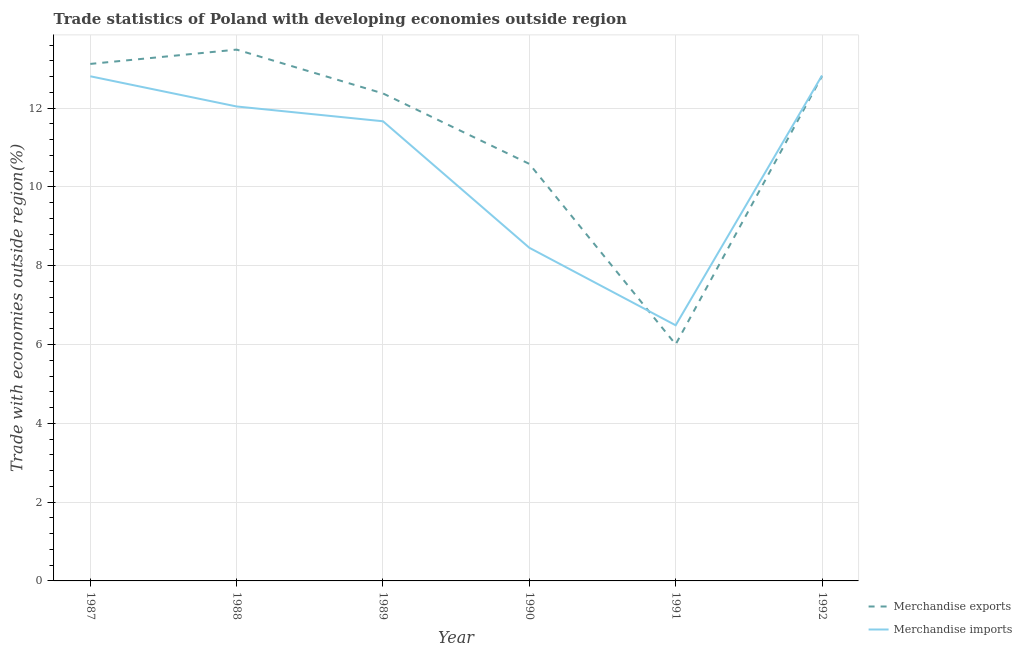How many different coloured lines are there?
Make the answer very short. 2. Is the number of lines equal to the number of legend labels?
Offer a very short reply. Yes. What is the merchandise imports in 1989?
Your answer should be very brief. 11.67. Across all years, what is the maximum merchandise imports?
Provide a short and direct response. 12.83. Across all years, what is the minimum merchandise imports?
Offer a very short reply. 6.49. In which year was the merchandise exports maximum?
Ensure brevity in your answer.  1988. What is the total merchandise imports in the graph?
Provide a succinct answer. 64.28. What is the difference between the merchandise imports in 1989 and that in 1990?
Your response must be concise. 3.21. What is the difference between the merchandise imports in 1989 and the merchandise exports in 1992?
Ensure brevity in your answer.  -1.14. What is the average merchandise imports per year?
Make the answer very short. 10.71. In the year 1990, what is the difference between the merchandise imports and merchandise exports?
Offer a very short reply. -2.13. What is the ratio of the merchandise exports in 1990 to that in 1992?
Give a very brief answer. 0.83. Is the merchandise imports in 1989 less than that in 1991?
Your answer should be compact. No. Is the difference between the merchandise exports in 1991 and 1992 greater than the difference between the merchandise imports in 1991 and 1992?
Offer a terse response. No. What is the difference between the highest and the second highest merchandise imports?
Ensure brevity in your answer.  0.02. What is the difference between the highest and the lowest merchandise exports?
Provide a short and direct response. 7.48. In how many years, is the merchandise imports greater than the average merchandise imports taken over all years?
Your answer should be compact. 4. How many years are there in the graph?
Make the answer very short. 6. What is the difference between two consecutive major ticks on the Y-axis?
Ensure brevity in your answer.  2. Are the values on the major ticks of Y-axis written in scientific E-notation?
Keep it short and to the point. No. Does the graph contain any zero values?
Ensure brevity in your answer.  No. Does the graph contain grids?
Offer a terse response. Yes. Where does the legend appear in the graph?
Your answer should be very brief. Bottom right. How many legend labels are there?
Keep it short and to the point. 2. What is the title of the graph?
Make the answer very short. Trade statistics of Poland with developing economies outside region. Does "Tetanus" appear as one of the legend labels in the graph?
Provide a succinct answer. No. What is the label or title of the X-axis?
Your response must be concise. Year. What is the label or title of the Y-axis?
Offer a very short reply. Trade with economies outside region(%). What is the Trade with economies outside region(%) of Merchandise exports in 1987?
Your answer should be compact. 13.12. What is the Trade with economies outside region(%) in Merchandise imports in 1987?
Your response must be concise. 12.81. What is the Trade with economies outside region(%) of Merchandise exports in 1988?
Give a very brief answer. 13.48. What is the Trade with economies outside region(%) of Merchandise imports in 1988?
Give a very brief answer. 12.04. What is the Trade with economies outside region(%) in Merchandise exports in 1989?
Your response must be concise. 12.37. What is the Trade with economies outside region(%) in Merchandise imports in 1989?
Make the answer very short. 11.67. What is the Trade with economies outside region(%) in Merchandise exports in 1990?
Offer a very short reply. 10.58. What is the Trade with economies outside region(%) in Merchandise imports in 1990?
Provide a succinct answer. 8.45. What is the Trade with economies outside region(%) in Merchandise exports in 1991?
Provide a succinct answer. 6. What is the Trade with economies outside region(%) of Merchandise imports in 1991?
Your answer should be very brief. 6.49. What is the Trade with economies outside region(%) in Merchandise exports in 1992?
Your response must be concise. 12.81. What is the Trade with economies outside region(%) of Merchandise imports in 1992?
Offer a very short reply. 12.83. Across all years, what is the maximum Trade with economies outside region(%) of Merchandise exports?
Provide a succinct answer. 13.48. Across all years, what is the maximum Trade with economies outside region(%) in Merchandise imports?
Make the answer very short. 12.83. Across all years, what is the minimum Trade with economies outside region(%) of Merchandise exports?
Your response must be concise. 6. Across all years, what is the minimum Trade with economies outside region(%) of Merchandise imports?
Your response must be concise. 6.49. What is the total Trade with economies outside region(%) in Merchandise exports in the graph?
Offer a terse response. 68.38. What is the total Trade with economies outside region(%) of Merchandise imports in the graph?
Your answer should be compact. 64.28. What is the difference between the Trade with economies outside region(%) in Merchandise exports in 1987 and that in 1988?
Ensure brevity in your answer.  -0.36. What is the difference between the Trade with economies outside region(%) of Merchandise imports in 1987 and that in 1988?
Offer a very short reply. 0.77. What is the difference between the Trade with economies outside region(%) in Merchandise exports in 1987 and that in 1989?
Your answer should be very brief. 0.75. What is the difference between the Trade with economies outside region(%) in Merchandise imports in 1987 and that in 1989?
Make the answer very short. 1.14. What is the difference between the Trade with economies outside region(%) of Merchandise exports in 1987 and that in 1990?
Provide a succinct answer. 2.54. What is the difference between the Trade with economies outside region(%) in Merchandise imports in 1987 and that in 1990?
Offer a very short reply. 4.35. What is the difference between the Trade with economies outside region(%) of Merchandise exports in 1987 and that in 1991?
Offer a very short reply. 7.12. What is the difference between the Trade with economies outside region(%) of Merchandise imports in 1987 and that in 1991?
Provide a succinct answer. 6.32. What is the difference between the Trade with economies outside region(%) in Merchandise exports in 1987 and that in 1992?
Offer a terse response. 0.31. What is the difference between the Trade with economies outside region(%) of Merchandise imports in 1987 and that in 1992?
Keep it short and to the point. -0.02. What is the difference between the Trade with economies outside region(%) of Merchandise exports in 1988 and that in 1989?
Your response must be concise. 1.11. What is the difference between the Trade with economies outside region(%) of Merchandise imports in 1988 and that in 1989?
Keep it short and to the point. 0.38. What is the difference between the Trade with economies outside region(%) of Merchandise exports in 1988 and that in 1990?
Offer a very short reply. 2.9. What is the difference between the Trade with economies outside region(%) in Merchandise imports in 1988 and that in 1990?
Offer a terse response. 3.59. What is the difference between the Trade with economies outside region(%) of Merchandise exports in 1988 and that in 1991?
Offer a very short reply. 7.48. What is the difference between the Trade with economies outside region(%) of Merchandise imports in 1988 and that in 1991?
Keep it short and to the point. 5.55. What is the difference between the Trade with economies outside region(%) of Merchandise exports in 1988 and that in 1992?
Provide a short and direct response. 0.67. What is the difference between the Trade with economies outside region(%) of Merchandise imports in 1988 and that in 1992?
Your response must be concise. -0.79. What is the difference between the Trade with economies outside region(%) in Merchandise exports in 1989 and that in 1990?
Your response must be concise. 1.79. What is the difference between the Trade with economies outside region(%) of Merchandise imports in 1989 and that in 1990?
Offer a terse response. 3.21. What is the difference between the Trade with economies outside region(%) of Merchandise exports in 1989 and that in 1991?
Ensure brevity in your answer.  6.37. What is the difference between the Trade with economies outside region(%) in Merchandise imports in 1989 and that in 1991?
Your response must be concise. 5.18. What is the difference between the Trade with economies outside region(%) of Merchandise exports in 1989 and that in 1992?
Your response must be concise. -0.44. What is the difference between the Trade with economies outside region(%) in Merchandise imports in 1989 and that in 1992?
Keep it short and to the point. -1.16. What is the difference between the Trade with economies outside region(%) of Merchandise exports in 1990 and that in 1991?
Provide a succinct answer. 4.58. What is the difference between the Trade with economies outside region(%) in Merchandise imports in 1990 and that in 1991?
Offer a terse response. 1.97. What is the difference between the Trade with economies outside region(%) in Merchandise exports in 1990 and that in 1992?
Keep it short and to the point. -2.23. What is the difference between the Trade with economies outside region(%) in Merchandise imports in 1990 and that in 1992?
Your answer should be compact. -4.37. What is the difference between the Trade with economies outside region(%) in Merchandise exports in 1991 and that in 1992?
Your answer should be very brief. -6.81. What is the difference between the Trade with economies outside region(%) of Merchandise imports in 1991 and that in 1992?
Offer a terse response. -6.34. What is the difference between the Trade with economies outside region(%) of Merchandise exports in 1987 and the Trade with economies outside region(%) of Merchandise imports in 1988?
Ensure brevity in your answer.  1.08. What is the difference between the Trade with economies outside region(%) in Merchandise exports in 1987 and the Trade with economies outside region(%) in Merchandise imports in 1989?
Make the answer very short. 1.46. What is the difference between the Trade with economies outside region(%) in Merchandise exports in 1987 and the Trade with economies outside region(%) in Merchandise imports in 1990?
Give a very brief answer. 4.67. What is the difference between the Trade with economies outside region(%) of Merchandise exports in 1987 and the Trade with economies outside region(%) of Merchandise imports in 1991?
Your answer should be compact. 6.63. What is the difference between the Trade with economies outside region(%) of Merchandise exports in 1987 and the Trade with economies outside region(%) of Merchandise imports in 1992?
Offer a very short reply. 0.29. What is the difference between the Trade with economies outside region(%) in Merchandise exports in 1988 and the Trade with economies outside region(%) in Merchandise imports in 1989?
Offer a terse response. 1.82. What is the difference between the Trade with economies outside region(%) of Merchandise exports in 1988 and the Trade with economies outside region(%) of Merchandise imports in 1990?
Keep it short and to the point. 5.03. What is the difference between the Trade with economies outside region(%) in Merchandise exports in 1988 and the Trade with economies outside region(%) in Merchandise imports in 1991?
Your response must be concise. 7. What is the difference between the Trade with economies outside region(%) of Merchandise exports in 1988 and the Trade with economies outside region(%) of Merchandise imports in 1992?
Give a very brief answer. 0.66. What is the difference between the Trade with economies outside region(%) of Merchandise exports in 1989 and the Trade with economies outside region(%) of Merchandise imports in 1990?
Provide a succinct answer. 3.92. What is the difference between the Trade with economies outside region(%) of Merchandise exports in 1989 and the Trade with economies outside region(%) of Merchandise imports in 1991?
Offer a very short reply. 5.88. What is the difference between the Trade with economies outside region(%) in Merchandise exports in 1989 and the Trade with economies outside region(%) in Merchandise imports in 1992?
Provide a succinct answer. -0.46. What is the difference between the Trade with economies outside region(%) of Merchandise exports in 1990 and the Trade with economies outside region(%) of Merchandise imports in 1991?
Your answer should be compact. 4.1. What is the difference between the Trade with economies outside region(%) in Merchandise exports in 1990 and the Trade with economies outside region(%) in Merchandise imports in 1992?
Offer a terse response. -2.24. What is the difference between the Trade with economies outside region(%) in Merchandise exports in 1991 and the Trade with economies outside region(%) in Merchandise imports in 1992?
Keep it short and to the point. -6.82. What is the average Trade with economies outside region(%) in Merchandise exports per year?
Make the answer very short. 11.4. What is the average Trade with economies outside region(%) in Merchandise imports per year?
Your answer should be very brief. 10.71. In the year 1987, what is the difference between the Trade with economies outside region(%) in Merchandise exports and Trade with economies outside region(%) in Merchandise imports?
Provide a succinct answer. 0.31. In the year 1988, what is the difference between the Trade with economies outside region(%) of Merchandise exports and Trade with economies outside region(%) of Merchandise imports?
Provide a short and direct response. 1.44. In the year 1989, what is the difference between the Trade with economies outside region(%) in Merchandise exports and Trade with economies outside region(%) in Merchandise imports?
Provide a short and direct response. 0.71. In the year 1990, what is the difference between the Trade with economies outside region(%) of Merchandise exports and Trade with economies outside region(%) of Merchandise imports?
Offer a terse response. 2.13. In the year 1991, what is the difference between the Trade with economies outside region(%) of Merchandise exports and Trade with economies outside region(%) of Merchandise imports?
Ensure brevity in your answer.  -0.48. In the year 1992, what is the difference between the Trade with economies outside region(%) of Merchandise exports and Trade with economies outside region(%) of Merchandise imports?
Keep it short and to the point. -0.02. What is the ratio of the Trade with economies outside region(%) in Merchandise exports in 1987 to that in 1988?
Give a very brief answer. 0.97. What is the ratio of the Trade with economies outside region(%) of Merchandise imports in 1987 to that in 1988?
Keep it short and to the point. 1.06. What is the ratio of the Trade with economies outside region(%) of Merchandise exports in 1987 to that in 1989?
Give a very brief answer. 1.06. What is the ratio of the Trade with economies outside region(%) of Merchandise imports in 1987 to that in 1989?
Your answer should be very brief. 1.1. What is the ratio of the Trade with economies outside region(%) in Merchandise exports in 1987 to that in 1990?
Ensure brevity in your answer.  1.24. What is the ratio of the Trade with economies outside region(%) in Merchandise imports in 1987 to that in 1990?
Ensure brevity in your answer.  1.51. What is the ratio of the Trade with economies outside region(%) of Merchandise exports in 1987 to that in 1991?
Your response must be concise. 2.19. What is the ratio of the Trade with economies outside region(%) in Merchandise imports in 1987 to that in 1991?
Give a very brief answer. 1.97. What is the ratio of the Trade with economies outside region(%) of Merchandise exports in 1987 to that in 1992?
Give a very brief answer. 1.02. What is the ratio of the Trade with economies outside region(%) of Merchandise exports in 1988 to that in 1989?
Make the answer very short. 1.09. What is the ratio of the Trade with economies outside region(%) of Merchandise imports in 1988 to that in 1989?
Your response must be concise. 1.03. What is the ratio of the Trade with economies outside region(%) of Merchandise exports in 1988 to that in 1990?
Provide a short and direct response. 1.27. What is the ratio of the Trade with economies outside region(%) in Merchandise imports in 1988 to that in 1990?
Ensure brevity in your answer.  1.42. What is the ratio of the Trade with economies outside region(%) of Merchandise exports in 1988 to that in 1991?
Keep it short and to the point. 2.25. What is the ratio of the Trade with economies outside region(%) of Merchandise imports in 1988 to that in 1991?
Your answer should be compact. 1.86. What is the ratio of the Trade with economies outside region(%) of Merchandise exports in 1988 to that in 1992?
Offer a terse response. 1.05. What is the ratio of the Trade with economies outside region(%) in Merchandise imports in 1988 to that in 1992?
Ensure brevity in your answer.  0.94. What is the ratio of the Trade with economies outside region(%) in Merchandise exports in 1989 to that in 1990?
Provide a succinct answer. 1.17. What is the ratio of the Trade with economies outside region(%) in Merchandise imports in 1989 to that in 1990?
Your answer should be compact. 1.38. What is the ratio of the Trade with economies outside region(%) in Merchandise exports in 1989 to that in 1991?
Offer a terse response. 2.06. What is the ratio of the Trade with economies outside region(%) in Merchandise imports in 1989 to that in 1991?
Provide a succinct answer. 1.8. What is the ratio of the Trade with economies outside region(%) of Merchandise exports in 1989 to that in 1992?
Give a very brief answer. 0.97. What is the ratio of the Trade with economies outside region(%) in Merchandise imports in 1989 to that in 1992?
Keep it short and to the point. 0.91. What is the ratio of the Trade with economies outside region(%) of Merchandise exports in 1990 to that in 1991?
Make the answer very short. 1.76. What is the ratio of the Trade with economies outside region(%) in Merchandise imports in 1990 to that in 1991?
Keep it short and to the point. 1.3. What is the ratio of the Trade with economies outside region(%) in Merchandise exports in 1990 to that in 1992?
Provide a succinct answer. 0.83. What is the ratio of the Trade with economies outside region(%) in Merchandise imports in 1990 to that in 1992?
Offer a very short reply. 0.66. What is the ratio of the Trade with economies outside region(%) in Merchandise exports in 1991 to that in 1992?
Ensure brevity in your answer.  0.47. What is the ratio of the Trade with economies outside region(%) of Merchandise imports in 1991 to that in 1992?
Provide a short and direct response. 0.51. What is the difference between the highest and the second highest Trade with economies outside region(%) of Merchandise exports?
Keep it short and to the point. 0.36. What is the difference between the highest and the second highest Trade with economies outside region(%) of Merchandise imports?
Your response must be concise. 0.02. What is the difference between the highest and the lowest Trade with economies outside region(%) in Merchandise exports?
Offer a very short reply. 7.48. What is the difference between the highest and the lowest Trade with economies outside region(%) of Merchandise imports?
Provide a short and direct response. 6.34. 